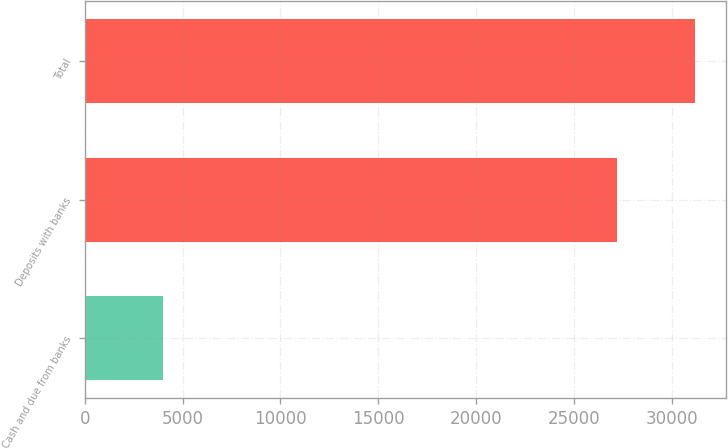Convert chart to OTSL. <chart><loc_0><loc_0><loc_500><loc_500><bar_chart><fcel>Cash and due from banks<fcel>Deposits with banks<fcel>Total<nl><fcel>4000<fcel>27208<fcel>31208<nl></chart> 